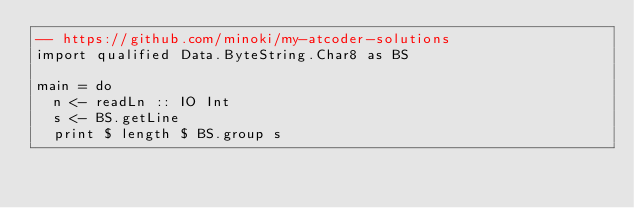<code> <loc_0><loc_0><loc_500><loc_500><_Haskell_>-- https://github.com/minoki/my-atcoder-solutions
import qualified Data.ByteString.Char8 as BS

main = do
  n <- readLn :: IO Int
  s <- BS.getLine
  print $ length $ BS.group s
</code> 